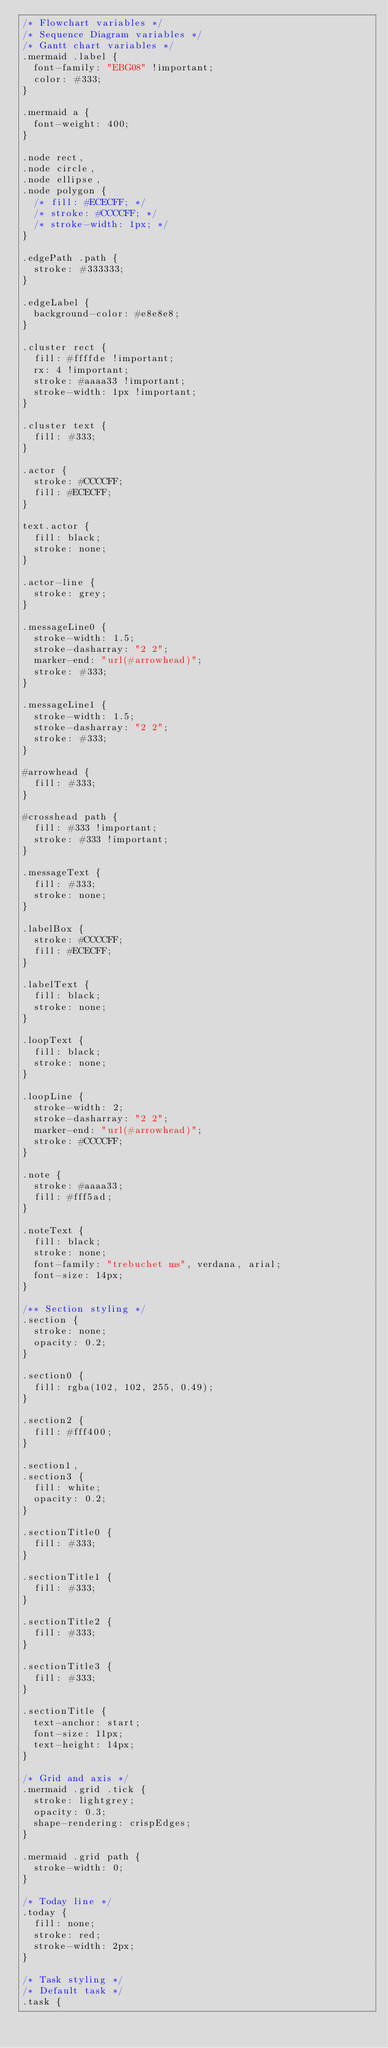<code> <loc_0><loc_0><loc_500><loc_500><_CSS_>/* Flowchart variables */
/* Sequence Diagram variables */
/* Gantt chart variables */
.mermaid .label {
  font-family: "EBG08" !important;
  color: #333;
}

.mermaid a {
  font-weight: 400;
}

.node rect,
.node circle,
.node ellipse,
.node polygon {
  /* fill: #ECECFF; */
  /* stroke: #CCCCFF; */
  /* stroke-width: 1px; */
}

.edgePath .path {
  stroke: #333333;
}

.edgeLabel {
  background-color: #e8e8e8;
}

.cluster rect {
  fill: #ffffde !important;
  rx: 4 !important;
  stroke: #aaaa33 !important;
  stroke-width: 1px !important;
}

.cluster text {
  fill: #333;
}

.actor {
  stroke: #CCCCFF;
  fill: #ECECFF;
}

text.actor {
  fill: black;
  stroke: none;
}

.actor-line {
  stroke: grey;
}

.messageLine0 {
  stroke-width: 1.5;
  stroke-dasharray: "2 2";
  marker-end: "url(#arrowhead)";
  stroke: #333;
}

.messageLine1 {
  stroke-width: 1.5;
  stroke-dasharray: "2 2";
  stroke: #333;
}

#arrowhead {
  fill: #333;
}

#crosshead path {
  fill: #333 !important;
  stroke: #333 !important;
}

.messageText {
  fill: #333;
  stroke: none;
}

.labelBox {
  stroke: #CCCCFF;
  fill: #ECECFF;
}

.labelText {
  fill: black;
  stroke: none;
}

.loopText {
  fill: black;
  stroke: none;
}

.loopLine {
  stroke-width: 2;
  stroke-dasharray: "2 2";
  marker-end: "url(#arrowhead)";
  stroke: #CCCCFF;
}

.note {
  stroke: #aaaa33;
  fill: #fff5ad;
}

.noteText {
  fill: black;
  stroke: none;
  font-family: "trebuchet ms", verdana, arial;
  font-size: 14px;
}

/** Section styling */
.section {
  stroke: none;
  opacity: 0.2;
}

.section0 {
  fill: rgba(102, 102, 255, 0.49);
}

.section2 {
  fill: #fff400;
}

.section1,
.section3 {
  fill: white;
  opacity: 0.2;
}

.sectionTitle0 {
  fill: #333;
}

.sectionTitle1 {
  fill: #333;
}

.sectionTitle2 {
  fill: #333;
}

.sectionTitle3 {
  fill: #333;
}

.sectionTitle {
  text-anchor: start;
  font-size: 11px;
  text-height: 14px;
}

/* Grid and axis */
.mermaid .grid .tick {
  stroke: lightgrey;
  opacity: 0.3;
  shape-rendering: crispEdges;
}

.mermaid .grid path {
  stroke-width: 0;
}

/* Today line */
.today {
  fill: none;
  stroke: red;
  stroke-width: 2px;
}

/* Task styling */
/* Default task */
.task {</code> 